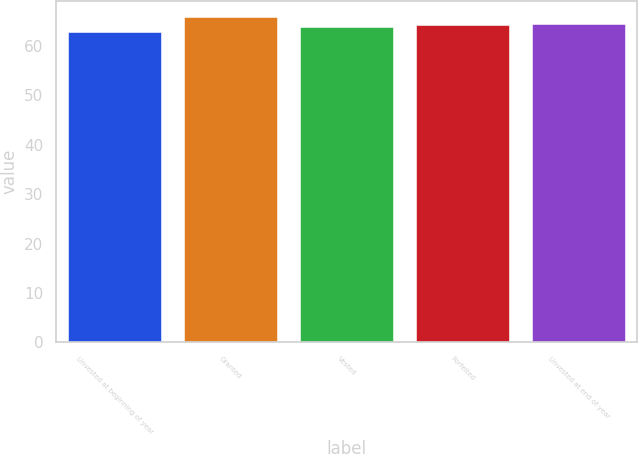Convert chart to OTSL. <chart><loc_0><loc_0><loc_500><loc_500><bar_chart><fcel>Unvested at beginning of year<fcel>Granted<fcel>Vested<fcel>Forfeited<fcel>Unvested at end of year<nl><fcel>62.75<fcel>65.79<fcel>63.92<fcel>64.22<fcel>64.52<nl></chart> 